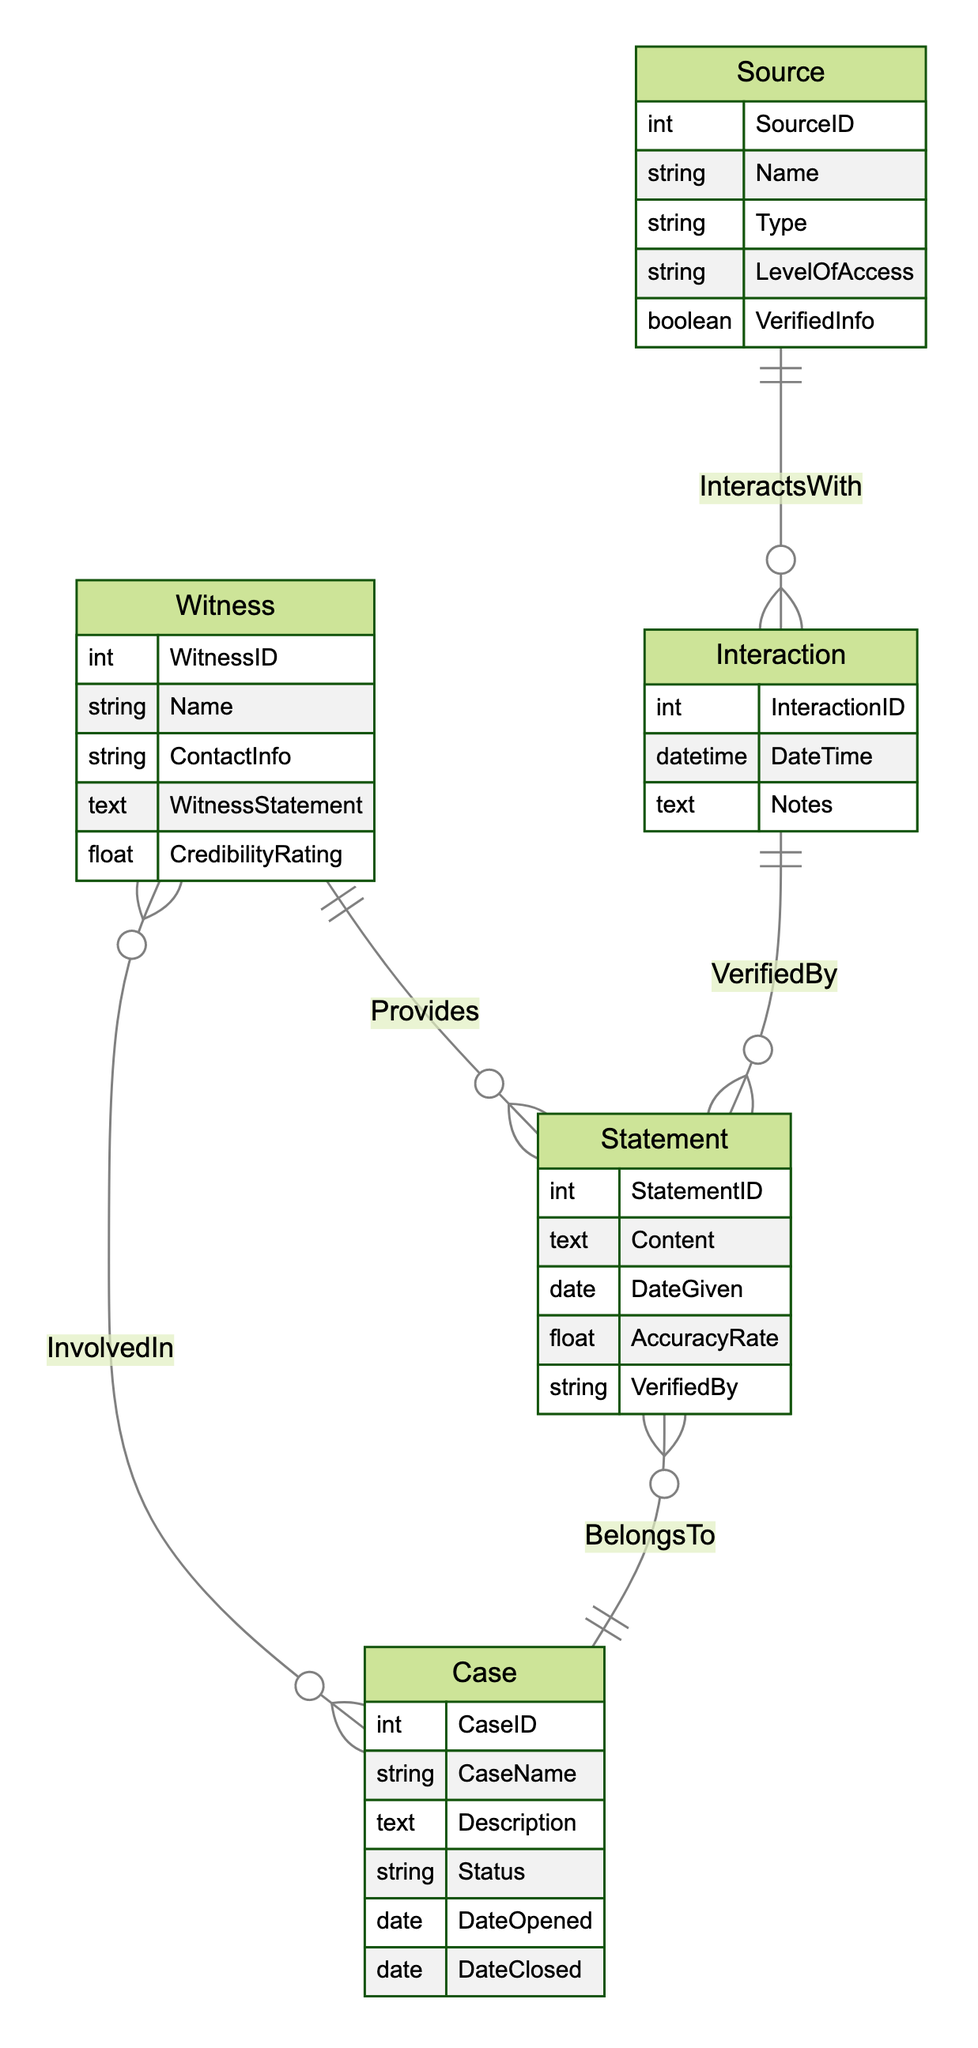What entities are present in the diagram? The diagram includes five entities: Witness, Case, Source, Interaction, and Statement.
Answer: Witness, Case, Source, Interaction, Statement How many attributes does the Statement entity have? The Statement entity has five attributes: StatementID, Content, DateGiven, AccuracyRate, and VerifiedBy.
Answer: 5 What relationship exists between Witness and Case? There is a many-to-many relationship named "InvolvedIn" between Witness and Case.
Answer: InvolvedIn Which entity provides statements? The Witness entity is the one that provides statements to the Statement entity.
Answer: Witness How many interactions can a Source have? A Source can have many interactions as indicated by the one-to-many relationship "InteractsWith" with Interaction.
Answer: Many What does the "VerifiedBy" relationship connect? The “VerifiedBy” relationship connects Interaction with Statement, indicating how statements are verified.
Answer: Interaction and Statement Which entity can have a credibility rating? The Witness entity has a credibility rating as one of its attributes.
Answer: Witness What attribute categorizes the Source's information? The VerifiedInfo attribute categorizes the Source’s information as valid or not.
Answer: VerifiedInfo Is the relationship between Statement and Case one-to-one or many-to-one? The relationship is many-to-one, as multiple statements can belong to a single case.
Answer: Many-to-one What attribute of the Statement indicates its accuracy? The AccuracyRate attribute of the Statement indicates its accuracy level.
Answer: AccuracyRate 